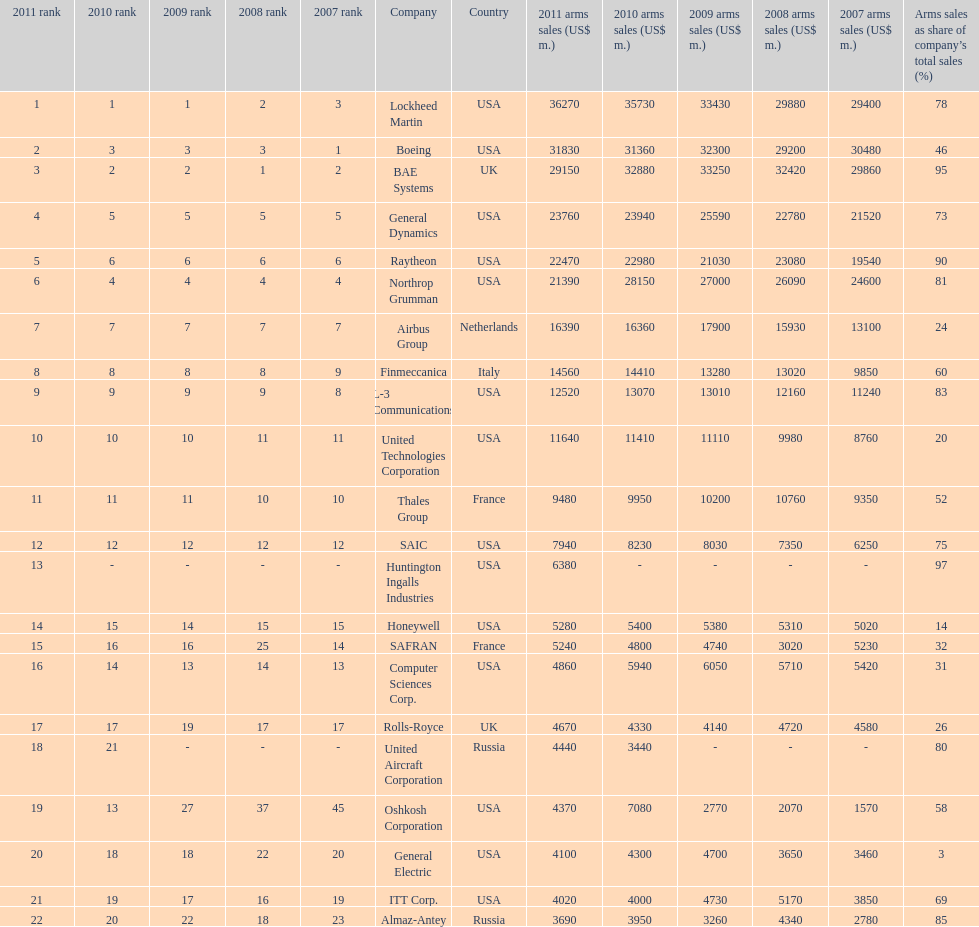What country is the first listed country? USA. Could you parse the entire table as a dict? {'header': ['2011 rank', '2010 rank', '2009 rank', '2008 rank', '2007 rank', 'Company', 'Country', '2011 arms sales (US$ m.)', '2010 arms sales (US$ m.)', '2009 arms sales (US$ m.)', '2008 arms sales (US$ m.)', '2007 arms sales (US$ m.)', 'Arms sales as share of company’s total sales (%)'], 'rows': [['1', '1', '1', '2', '3', 'Lockheed Martin', 'USA', '36270', '35730', '33430', '29880', '29400', '78'], ['2', '3', '3', '3', '1', 'Boeing', 'USA', '31830', '31360', '32300', '29200', '30480', '46'], ['3', '2', '2', '1', '2', 'BAE Systems', 'UK', '29150', '32880', '33250', '32420', '29860', '95'], ['4', '5', '5', '5', '5', 'General Dynamics', 'USA', '23760', '23940', '25590', '22780', '21520', '73'], ['5', '6', '6', '6', '6', 'Raytheon', 'USA', '22470', '22980', '21030', '23080', '19540', '90'], ['6', '4', '4', '4', '4', 'Northrop Grumman', 'USA', '21390', '28150', '27000', '26090', '24600', '81'], ['7', '7', '7', '7', '7', 'Airbus Group', 'Netherlands', '16390', '16360', '17900', '15930', '13100', '24'], ['8', '8', '8', '8', '9', 'Finmeccanica', 'Italy', '14560', '14410', '13280', '13020', '9850', '60'], ['9', '9', '9', '9', '8', 'L-3 Communications', 'USA', '12520', '13070', '13010', '12160', '11240', '83'], ['10', '10', '10', '11', '11', 'United Technologies Corporation', 'USA', '11640', '11410', '11110', '9980', '8760', '20'], ['11', '11', '11', '10', '10', 'Thales Group', 'France', '9480', '9950', '10200', '10760', '9350', '52'], ['12', '12', '12', '12', '12', 'SAIC', 'USA', '7940', '8230', '8030', '7350', '6250', '75'], ['13', '-', '-', '-', '-', 'Huntington Ingalls Industries', 'USA', '6380', '-', '-', '-', '-', '97'], ['14', '15', '14', '15', '15', 'Honeywell', 'USA', '5280', '5400', '5380', '5310', '5020', '14'], ['15', '16', '16', '25', '14', 'SAFRAN', 'France', '5240', '4800', '4740', '3020', '5230', '32'], ['16', '14', '13', '14', '13', 'Computer Sciences Corp.', 'USA', '4860', '5940', '6050', '5710', '5420', '31'], ['17', '17', '19', '17', '17', 'Rolls-Royce', 'UK', '4670', '4330', '4140', '4720', '4580', '26'], ['18', '21', '-', '-', '-', 'United Aircraft Corporation', 'Russia', '4440', '3440', '-', '-', '-', '80'], ['19', '13', '27', '37', '45', 'Oshkosh Corporation', 'USA', '4370', '7080', '2770', '2070', '1570', '58'], ['20', '18', '18', '22', '20', 'General Electric', 'USA', '4100', '4300', '4700', '3650', '3460', '3'], ['21', '19', '17', '16', '19', 'ITT Corp.', 'USA', '4020', '4000', '4730', '5170', '3850', '69'], ['22', '20', '22', '18', '23', 'Almaz-Antey', 'Russia', '3690', '3950', '3260', '4340', '2780', '85']]} 